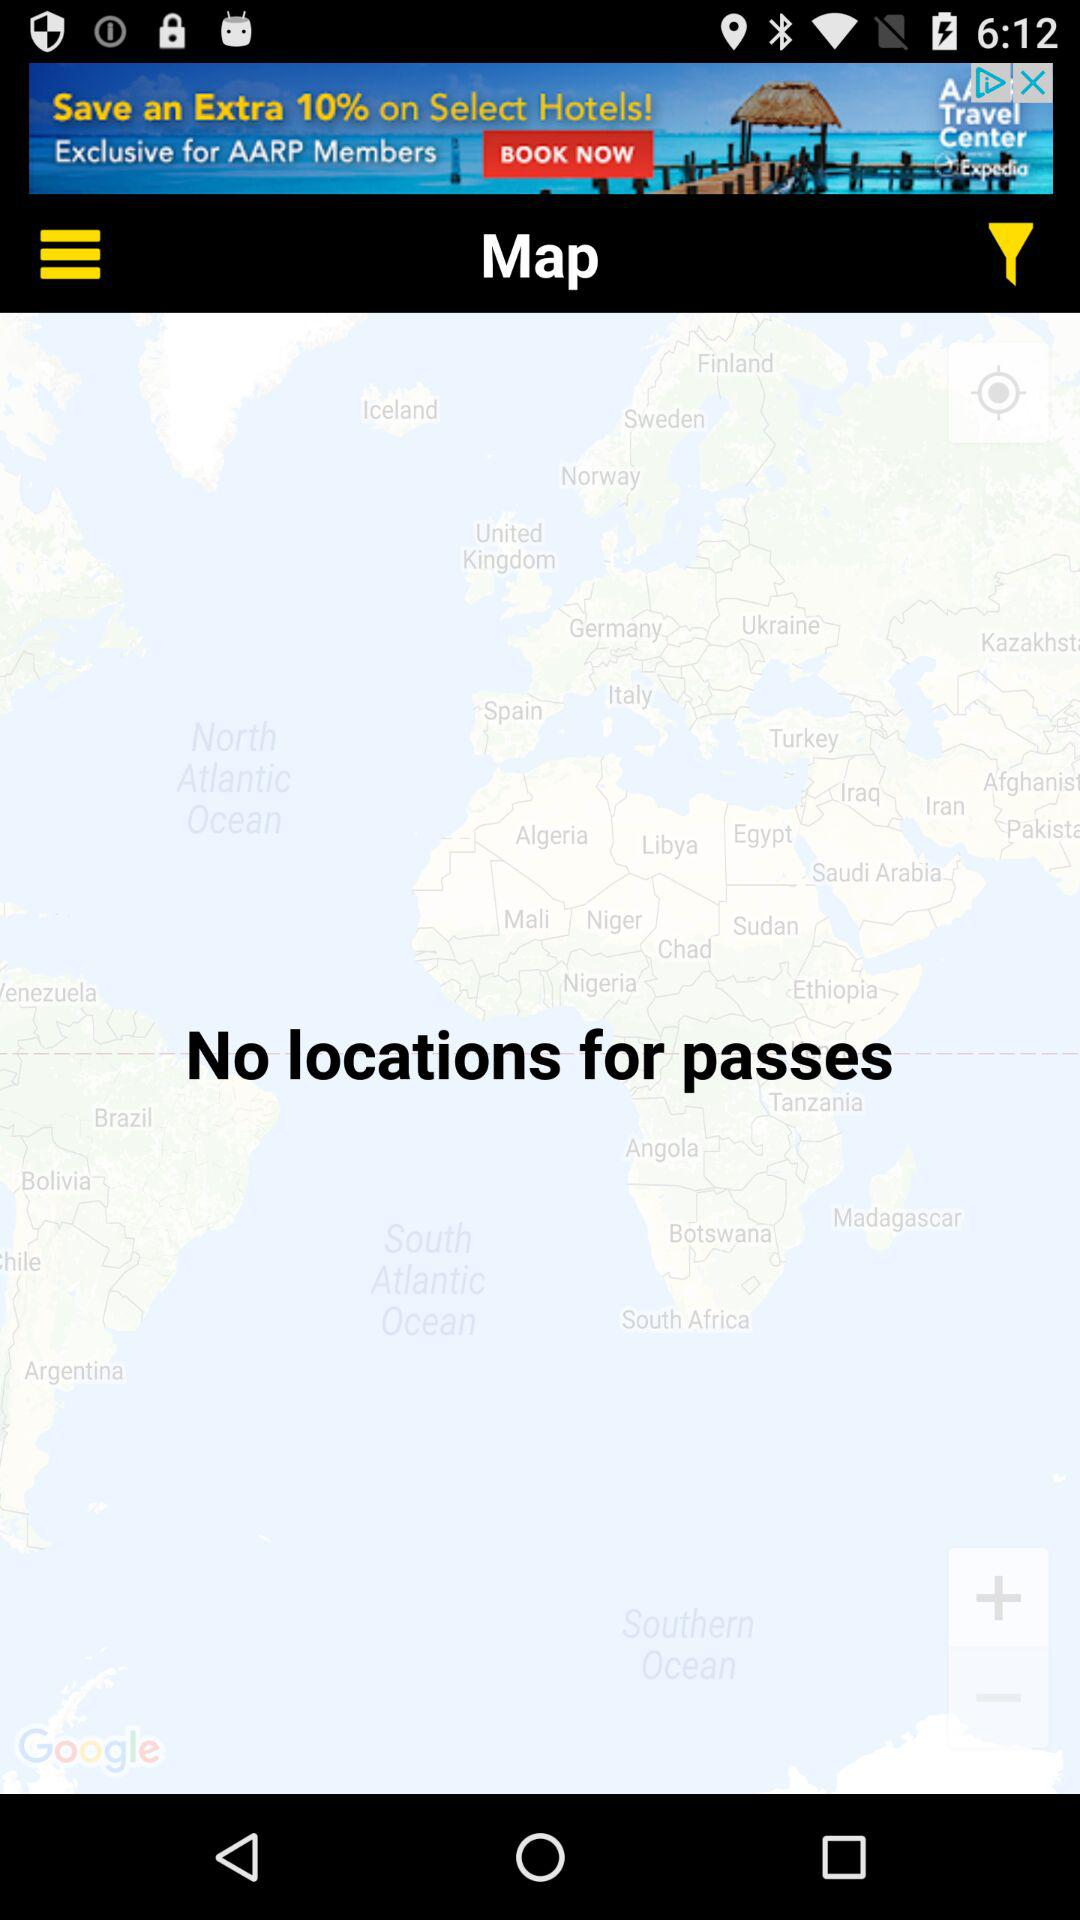How many locations are there for passes? There are no locations for passes. 